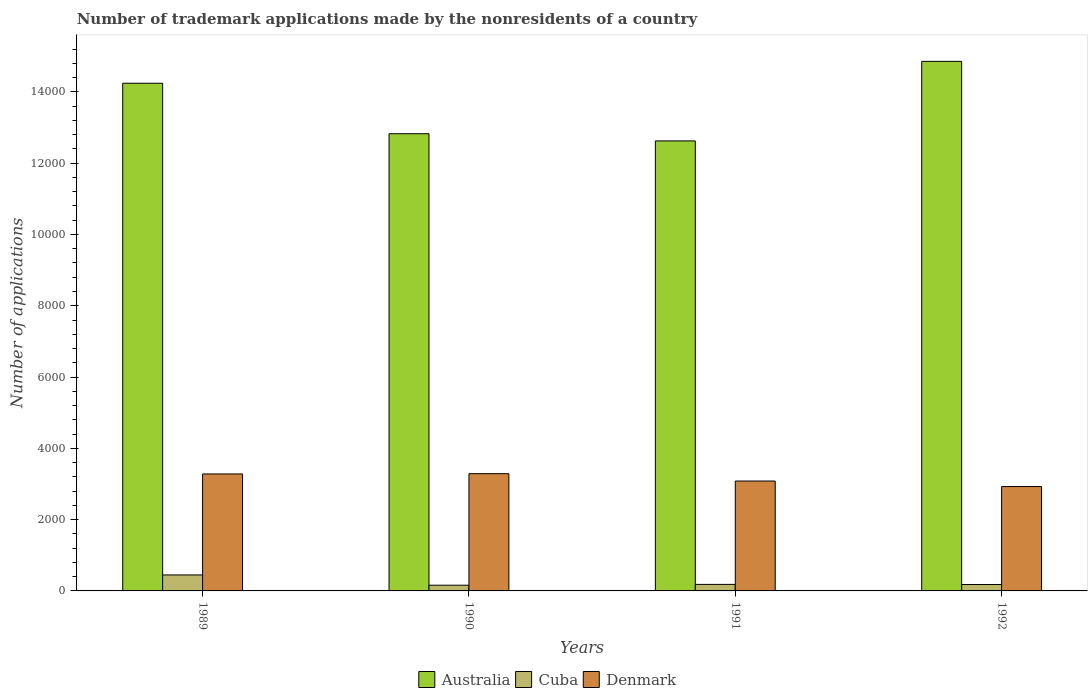How many different coloured bars are there?
Ensure brevity in your answer.  3. How many groups of bars are there?
Make the answer very short. 4. How many bars are there on the 2nd tick from the right?
Make the answer very short. 3. What is the number of trademark applications made by the nonresidents in Cuba in 1990?
Provide a short and direct response. 160. Across all years, what is the maximum number of trademark applications made by the nonresidents in Denmark?
Offer a terse response. 3289. Across all years, what is the minimum number of trademark applications made by the nonresidents in Denmark?
Ensure brevity in your answer.  2928. In which year was the number of trademark applications made by the nonresidents in Australia maximum?
Your response must be concise. 1992. In which year was the number of trademark applications made by the nonresidents in Denmark minimum?
Offer a terse response. 1992. What is the total number of trademark applications made by the nonresidents in Denmark in the graph?
Provide a succinct answer. 1.26e+04. What is the difference between the number of trademark applications made by the nonresidents in Australia in 1989 and the number of trademark applications made by the nonresidents in Denmark in 1991?
Provide a short and direct response. 1.12e+04. What is the average number of trademark applications made by the nonresidents in Denmark per year?
Give a very brief answer. 3145.25. In the year 1989, what is the difference between the number of trademark applications made by the nonresidents in Cuba and number of trademark applications made by the nonresidents in Denmark?
Give a very brief answer. -2833. What is the ratio of the number of trademark applications made by the nonresidents in Cuba in 1990 to that in 1991?
Provide a succinct answer. 0.87. Is the number of trademark applications made by the nonresidents in Australia in 1991 less than that in 1992?
Offer a terse response. Yes. Is the difference between the number of trademark applications made by the nonresidents in Cuba in 1989 and 1991 greater than the difference between the number of trademark applications made by the nonresidents in Denmark in 1989 and 1991?
Offer a terse response. Yes. What is the difference between the highest and the second highest number of trademark applications made by the nonresidents in Denmark?
Provide a short and direct response. 8. What is the difference between the highest and the lowest number of trademark applications made by the nonresidents in Australia?
Ensure brevity in your answer.  2232. Is it the case that in every year, the sum of the number of trademark applications made by the nonresidents in Australia and number of trademark applications made by the nonresidents in Denmark is greater than the number of trademark applications made by the nonresidents in Cuba?
Offer a very short reply. Yes. How many bars are there?
Offer a terse response. 12. How many years are there in the graph?
Give a very brief answer. 4. How many legend labels are there?
Give a very brief answer. 3. How are the legend labels stacked?
Your answer should be very brief. Horizontal. What is the title of the graph?
Make the answer very short. Number of trademark applications made by the nonresidents of a country. What is the label or title of the X-axis?
Ensure brevity in your answer.  Years. What is the label or title of the Y-axis?
Keep it short and to the point. Number of applications. What is the Number of applications in Australia in 1989?
Provide a succinct answer. 1.42e+04. What is the Number of applications of Cuba in 1989?
Offer a very short reply. 448. What is the Number of applications in Denmark in 1989?
Provide a succinct answer. 3281. What is the Number of applications of Australia in 1990?
Ensure brevity in your answer.  1.28e+04. What is the Number of applications of Cuba in 1990?
Provide a succinct answer. 160. What is the Number of applications in Denmark in 1990?
Provide a short and direct response. 3289. What is the Number of applications of Australia in 1991?
Give a very brief answer. 1.26e+04. What is the Number of applications of Cuba in 1991?
Your answer should be compact. 183. What is the Number of applications in Denmark in 1991?
Give a very brief answer. 3083. What is the Number of applications in Australia in 1992?
Offer a very short reply. 1.49e+04. What is the Number of applications of Cuba in 1992?
Give a very brief answer. 180. What is the Number of applications in Denmark in 1992?
Your answer should be very brief. 2928. Across all years, what is the maximum Number of applications of Australia?
Keep it short and to the point. 1.49e+04. Across all years, what is the maximum Number of applications in Cuba?
Ensure brevity in your answer.  448. Across all years, what is the maximum Number of applications in Denmark?
Your answer should be very brief. 3289. Across all years, what is the minimum Number of applications of Australia?
Offer a very short reply. 1.26e+04. Across all years, what is the minimum Number of applications in Cuba?
Make the answer very short. 160. Across all years, what is the minimum Number of applications of Denmark?
Ensure brevity in your answer.  2928. What is the total Number of applications in Australia in the graph?
Your answer should be very brief. 5.45e+04. What is the total Number of applications in Cuba in the graph?
Ensure brevity in your answer.  971. What is the total Number of applications in Denmark in the graph?
Provide a short and direct response. 1.26e+04. What is the difference between the Number of applications of Australia in 1989 and that in 1990?
Offer a very short reply. 1416. What is the difference between the Number of applications in Cuba in 1989 and that in 1990?
Offer a terse response. 288. What is the difference between the Number of applications of Australia in 1989 and that in 1991?
Give a very brief answer. 1618. What is the difference between the Number of applications in Cuba in 1989 and that in 1991?
Your answer should be compact. 265. What is the difference between the Number of applications of Denmark in 1989 and that in 1991?
Your answer should be compact. 198. What is the difference between the Number of applications of Australia in 1989 and that in 1992?
Provide a short and direct response. -614. What is the difference between the Number of applications of Cuba in 1989 and that in 1992?
Provide a short and direct response. 268. What is the difference between the Number of applications in Denmark in 1989 and that in 1992?
Provide a short and direct response. 353. What is the difference between the Number of applications in Australia in 1990 and that in 1991?
Keep it short and to the point. 202. What is the difference between the Number of applications in Cuba in 1990 and that in 1991?
Provide a short and direct response. -23. What is the difference between the Number of applications of Denmark in 1990 and that in 1991?
Give a very brief answer. 206. What is the difference between the Number of applications in Australia in 1990 and that in 1992?
Provide a succinct answer. -2030. What is the difference between the Number of applications in Denmark in 1990 and that in 1992?
Your response must be concise. 361. What is the difference between the Number of applications of Australia in 1991 and that in 1992?
Give a very brief answer. -2232. What is the difference between the Number of applications in Cuba in 1991 and that in 1992?
Provide a succinct answer. 3. What is the difference between the Number of applications of Denmark in 1991 and that in 1992?
Your answer should be compact. 155. What is the difference between the Number of applications in Australia in 1989 and the Number of applications in Cuba in 1990?
Your answer should be compact. 1.41e+04. What is the difference between the Number of applications of Australia in 1989 and the Number of applications of Denmark in 1990?
Your response must be concise. 1.10e+04. What is the difference between the Number of applications in Cuba in 1989 and the Number of applications in Denmark in 1990?
Your answer should be very brief. -2841. What is the difference between the Number of applications of Australia in 1989 and the Number of applications of Cuba in 1991?
Make the answer very short. 1.41e+04. What is the difference between the Number of applications of Australia in 1989 and the Number of applications of Denmark in 1991?
Your response must be concise. 1.12e+04. What is the difference between the Number of applications in Cuba in 1989 and the Number of applications in Denmark in 1991?
Give a very brief answer. -2635. What is the difference between the Number of applications in Australia in 1989 and the Number of applications in Cuba in 1992?
Give a very brief answer. 1.41e+04. What is the difference between the Number of applications of Australia in 1989 and the Number of applications of Denmark in 1992?
Keep it short and to the point. 1.13e+04. What is the difference between the Number of applications in Cuba in 1989 and the Number of applications in Denmark in 1992?
Make the answer very short. -2480. What is the difference between the Number of applications in Australia in 1990 and the Number of applications in Cuba in 1991?
Your answer should be compact. 1.26e+04. What is the difference between the Number of applications in Australia in 1990 and the Number of applications in Denmark in 1991?
Provide a succinct answer. 9743. What is the difference between the Number of applications in Cuba in 1990 and the Number of applications in Denmark in 1991?
Provide a short and direct response. -2923. What is the difference between the Number of applications of Australia in 1990 and the Number of applications of Cuba in 1992?
Ensure brevity in your answer.  1.26e+04. What is the difference between the Number of applications of Australia in 1990 and the Number of applications of Denmark in 1992?
Make the answer very short. 9898. What is the difference between the Number of applications in Cuba in 1990 and the Number of applications in Denmark in 1992?
Your answer should be very brief. -2768. What is the difference between the Number of applications in Australia in 1991 and the Number of applications in Cuba in 1992?
Offer a very short reply. 1.24e+04. What is the difference between the Number of applications in Australia in 1991 and the Number of applications in Denmark in 1992?
Provide a short and direct response. 9696. What is the difference between the Number of applications in Cuba in 1991 and the Number of applications in Denmark in 1992?
Keep it short and to the point. -2745. What is the average Number of applications in Australia per year?
Make the answer very short. 1.36e+04. What is the average Number of applications of Cuba per year?
Offer a terse response. 242.75. What is the average Number of applications of Denmark per year?
Your response must be concise. 3145.25. In the year 1989, what is the difference between the Number of applications of Australia and Number of applications of Cuba?
Offer a terse response. 1.38e+04. In the year 1989, what is the difference between the Number of applications of Australia and Number of applications of Denmark?
Keep it short and to the point. 1.10e+04. In the year 1989, what is the difference between the Number of applications of Cuba and Number of applications of Denmark?
Your response must be concise. -2833. In the year 1990, what is the difference between the Number of applications of Australia and Number of applications of Cuba?
Provide a short and direct response. 1.27e+04. In the year 1990, what is the difference between the Number of applications of Australia and Number of applications of Denmark?
Make the answer very short. 9537. In the year 1990, what is the difference between the Number of applications in Cuba and Number of applications in Denmark?
Your answer should be compact. -3129. In the year 1991, what is the difference between the Number of applications of Australia and Number of applications of Cuba?
Your answer should be compact. 1.24e+04. In the year 1991, what is the difference between the Number of applications of Australia and Number of applications of Denmark?
Provide a succinct answer. 9541. In the year 1991, what is the difference between the Number of applications of Cuba and Number of applications of Denmark?
Your answer should be very brief. -2900. In the year 1992, what is the difference between the Number of applications of Australia and Number of applications of Cuba?
Give a very brief answer. 1.47e+04. In the year 1992, what is the difference between the Number of applications of Australia and Number of applications of Denmark?
Your response must be concise. 1.19e+04. In the year 1992, what is the difference between the Number of applications of Cuba and Number of applications of Denmark?
Your answer should be very brief. -2748. What is the ratio of the Number of applications in Australia in 1989 to that in 1990?
Offer a terse response. 1.11. What is the ratio of the Number of applications in Cuba in 1989 to that in 1990?
Ensure brevity in your answer.  2.8. What is the ratio of the Number of applications of Denmark in 1989 to that in 1990?
Offer a terse response. 1. What is the ratio of the Number of applications of Australia in 1989 to that in 1991?
Offer a terse response. 1.13. What is the ratio of the Number of applications of Cuba in 1989 to that in 1991?
Your answer should be compact. 2.45. What is the ratio of the Number of applications in Denmark in 1989 to that in 1991?
Offer a terse response. 1.06. What is the ratio of the Number of applications of Australia in 1989 to that in 1992?
Ensure brevity in your answer.  0.96. What is the ratio of the Number of applications of Cuba in 1989 to that in 1992?
Your response must be concise. 2.49. What is the ratio of the Number of applications of Denmark in 1989 to that in 1992?
Give a very brief answer. 1.12. What is the ratio of the Number of applications of Australia in 1990 to that in 1991?
Your response must be concise. 1.02. What is the ratio of the Number of applications in Cuba in 1990 to that in 1991?
Make the answer very short. 0.87. What is the ratio of the Number of applications of Denmark in 1990 to that in 1991?
Your answer should be very brief. 1.07. What is the ratio of the Number of applications of Australia in 1990 to that in 1992?
Give a very brief answer. 0.86. What is the ratio of the Number of applications in Denmark in 1990 to that in 1992?
Your answer should be compact. 1.12. What is the ratio of the Number of applications of Australia in 1991 to that in 1992?
Keep it short and to the point. 0.85. What is the ratio of the Number of applications of Cuba in 1991 to that in 1992?
Provide a succinct answer. 1.02. What is the ratio of the Number of applications in Denmark in 1991 to that in 1992?
Keep it short and to the point. 1.05. What is the difference between the highest and the second highest Number of applications in Australia?
Make the answer very short. 614. What is the difference between the highest and the second highest Number of applications in Cuba?
Offer a very short reply. 265. What is the difference between the highest and the lowest Number of applications of Australia?
Ensure brevity in your answer.  2232. What is the difference between the highest and the lowest Number of applications of Cuba?
Offer a terse response. 288. What is the difference between the highest and the lowest Number of applications of Denmark?
Your answer should be compact. 361. 